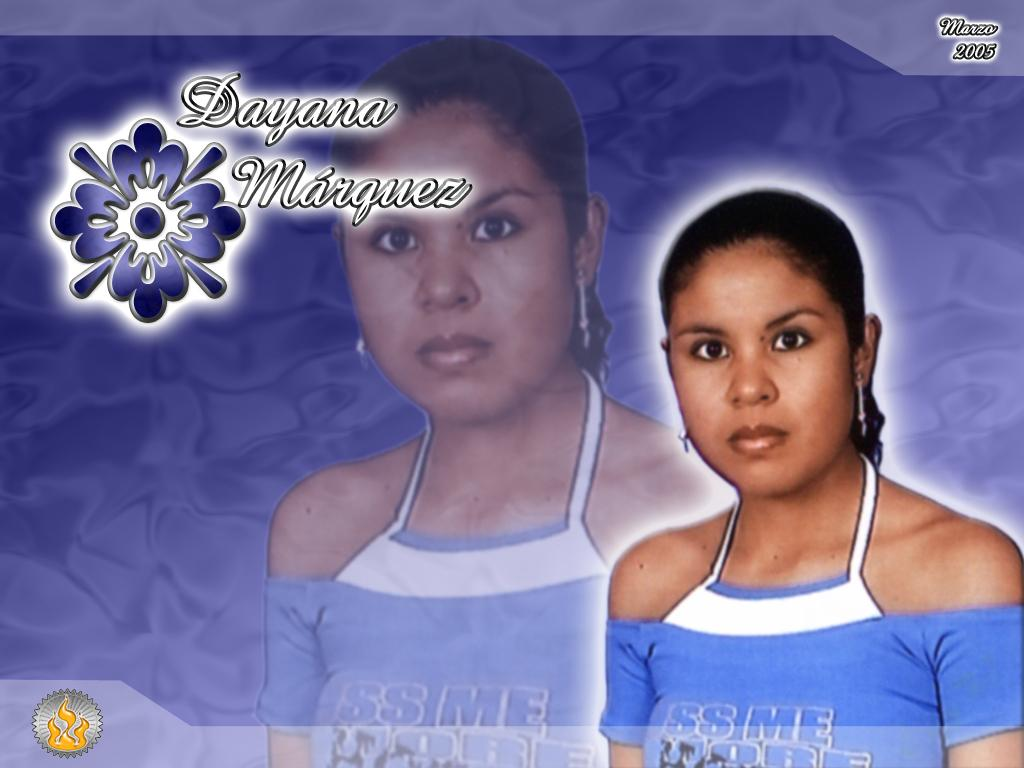<image>
Share a concise interpretation of the image provided. A picture of a woman named Dayana Marquez. 